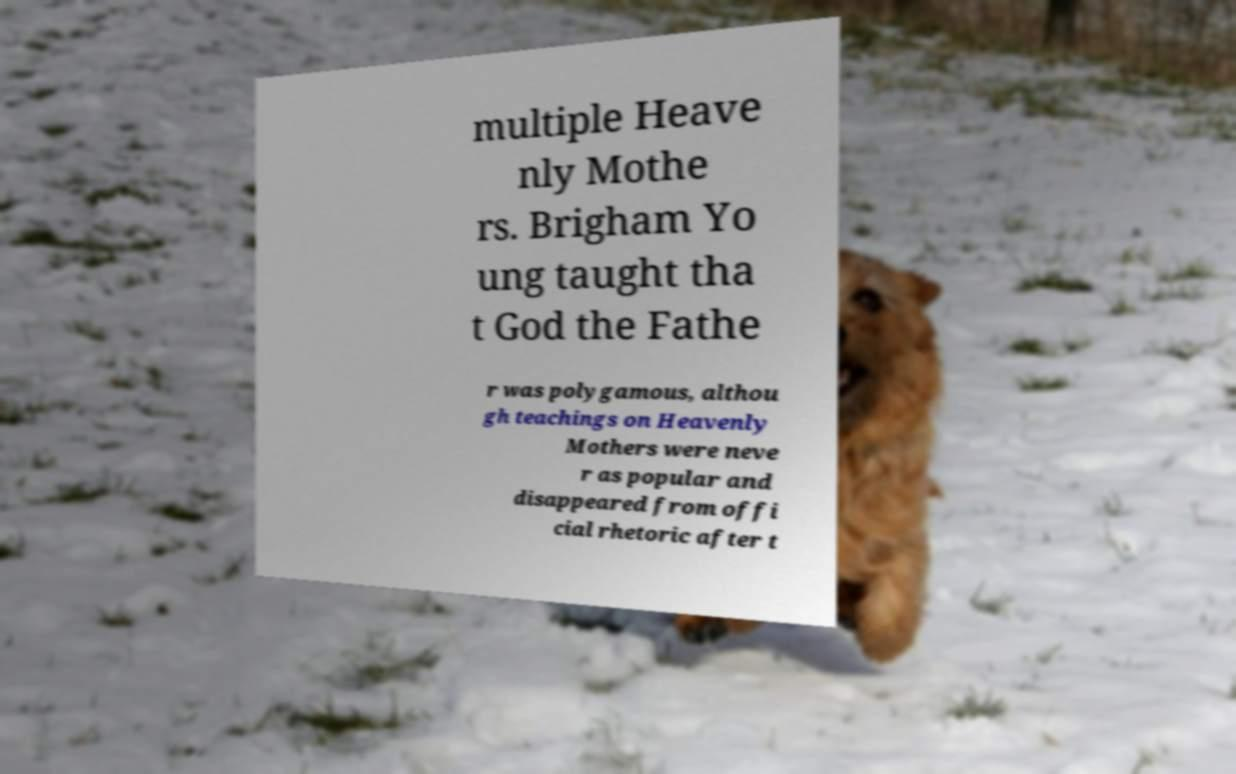Please read and relay the text visible in this image. What does it say? multiple Heave nly Mothe rs. Brigham Yo ung taught tha t God the Fathe r was polygamous, althou gh teachings on Heavenly Mothers were neve r as popular and disappeared from offi cial rhetoric after t 